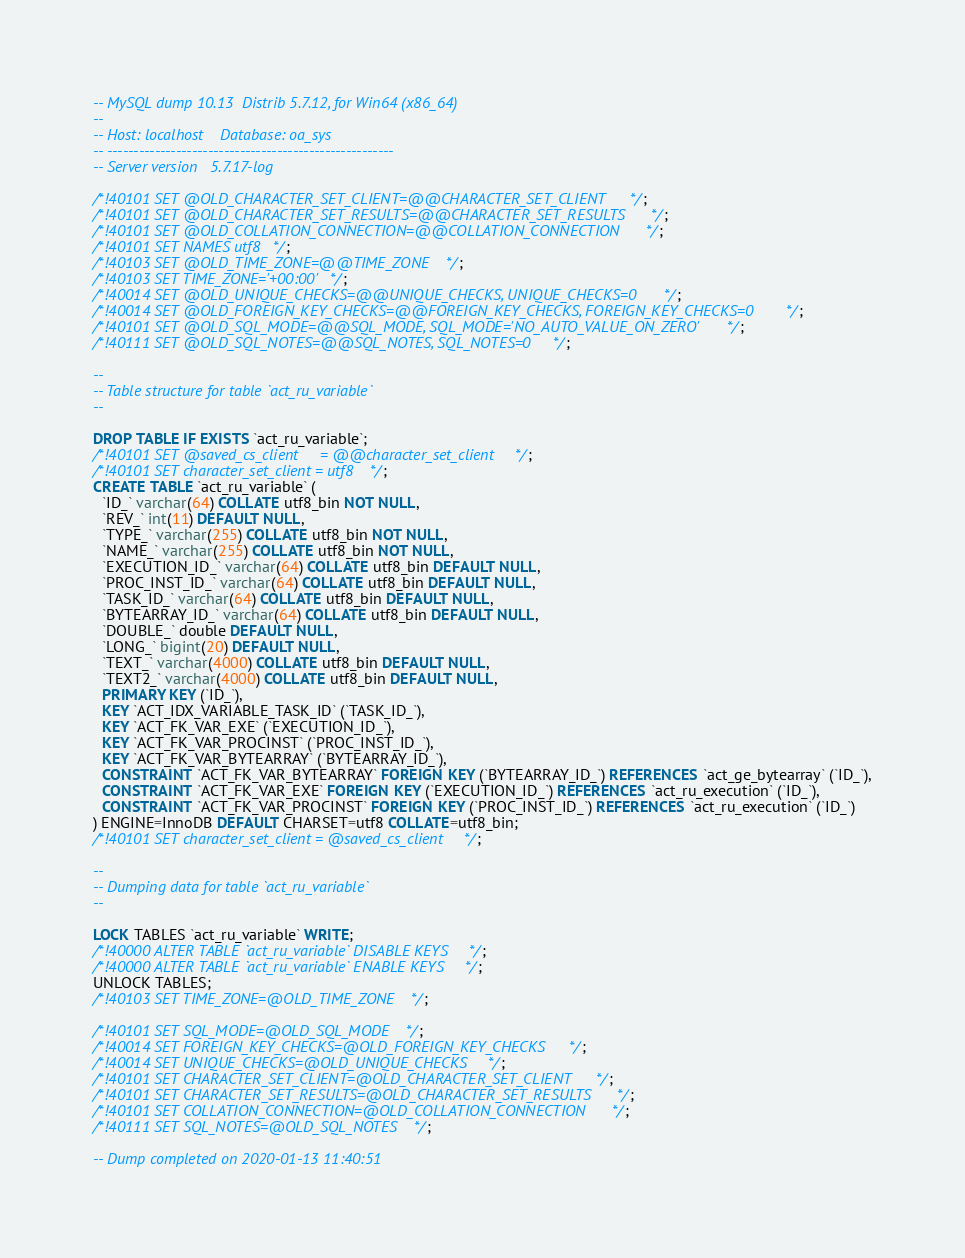<code> <loc_0><loc_0><loc_500><loc_500><_SQL_>-- MySQL dump 10.13  Distrib 5.7.12, for Win64 (x86_64)
--
-- Host: localhost    Database: oa_sys
-- ------------------------------------------------------
-- Server version	5.7.17-log

/*!40101 SET @OLD_CHARACTER_SET_CLIENT=@@CHARACTER_SET_CLIENT */;
/*!40101 SET @OLD_CHARACTER_SET_RESULTS=@@CHARACTER_SET_RESULTS */;
/*!40101 SET @OLD_COLLATION_CONNECTION=@@COLLATION_CONNECTION */;
/*!40101 SET NAMES utf8 */;
/*!40103 SET @OLD_TIME_ZONE=@@TIME_ZONE */;
/*!40103 SET TIME_ZONE='+00:00' */;
/*!40014 SET @OLD_UNIQUE_CHECKS=@@UNIQUE_CHECKS, UNIQUE_CHECKS=0 */;
/*!40014 SET @OLD_FOREIGN_KEY_CHECKS=@@FOREIGN_KEY_CHECKS, FOREIGN_KEY_CHECKS=0 */;
/*!40101 SET @OLD_SQL_MODE=@@SQL_MODE, SQL_MODE='NO_AUTO_VALUE_ON_ZERO' */;
/*!40111 SET @OLD_SQL_NOTES=@@SQL_NOTES, SQL_NOTES=0 */;

--
-- Table structure for table `act_ru_variable`
--

DROP TABLE IF EXISTS `act_ru_variable`;
/*!40101 SET @saved_cs_client     = @@character_set_client */;
/*!40101 SET character_set_client = utf8 */;
CREATE TABLE `act_ru_variable` (
  `ID_` varchar(64) COLLATE utf8_bin NOT NULL,
  `REV_` int(11) DEFAULT NULL,
  `TYPE_` varchar(255) COLLATE utf8_bin NOT NULL,
  `NAME_` varchar(255) COLLATE utf8_bin NOT NULL,
  `EXECUTION_ID_` varchar(64) COLLATE utf8_bin DEFAULT NULL,
  `PROC_INST_ID_` varchar(64) COLLATE utf8_bin DEFAULT NULL,
  `TASK_ID_` varchar(64) COLLATE utf8_bin DEFAULT NULL,
  `BYTEARRAY_ID_` varchar(64) COLLATE utf8_bin DEFAULT NULL,
  `DOUBLE_` double DEFAULT NULL,
  `LONG_` bigint(20) DEFAULT NULL,
  `TEXT_` varchar(4000) COLLATE utf8_bin DEFAULT NULL,
  `TEXT2_` varchar(4000) COLLATE utf8_bin DEFAULT NULL,
  PRIMARY KEY (`ID_`),
  KEY `ACT_IDX_VARIABLE_TASK_ID` (`TASK_ID_`),
  KEY `ACT_FK_VAR_EXE` (`EXECUTION_ID_`),
  KEY `ACT_FK_VAR_PROCINST` (`PROC_INST_ID_`),
  KEY `ACT_FK_VAR_BYTEARRAY` (`BYTEARRAY_ID_`),
  CONSTRAINT `ACT_FK_VAR_BYTEARRAY` FOREIGN KEY (`BYTEARRAY_ID_`) REFERENCES `act_ge_bytearray` (`ID_`),
  CONSTRAINT `ACT_FK_VAR_EXE` FOREIGN KEY (`EXECUTION_ID_`) REFERENCES `act_ru_execution` (`ID_`),
  CONSTRAINT `ACT_FK_VAR_PROCINST` FOREIGN KEY (`PROC_INST_ID_`) REFERENCES `act_ru_execution` (`ID_`)
) ENGINE=InnoDB DEFAULT CHARSET=utf8 COLLATE=utf8_bin;
/*!40101 SET character_set_client = @saved_cs_client */;

--
-- Dumping data for table `act_ru_variable`
--

LOCK TABLES `act_ru_variable` WRITE;
/*!40000 ALTER TABLE `act_ru_variable` DISABLE KEYS */;
/*!40000 ALTER TABLE `act_ru_variable` ENABLE KEYS */;
UNLOCK TABLES;
/*!40103 SET TIME_ZONE=@OLD_TIME_ZONE */;

/*!40101 SET SQL_MODE=@OLD_SQL_MODE */;
/*!40014 SET FOREIGN_KEY_CHECKS=@OLD_FOREIGN_KEY_CHECKS */;
/*!40014 SET UNIQUE_CHECKS=@OLD_UNIQUE_CHECKS */;
/*!40101 SET CHARACTER_SET_CLIENT=@OLD_CHARACTER_SET_CLIENT */;
/*!40101 SET CHARACTER_SET_RESULTS=@OLD_CHARACTER_SET_RESULTS */;
/*!40101 SET COLLATION_CONNECTION=@OLD_COLLATION_CONNECTION */;
/*!40111 SET SQL_NOTES=@OLD_SQL_NOTES */;

-- Dump completed on 2020-01-13 11:40:51
</code> 